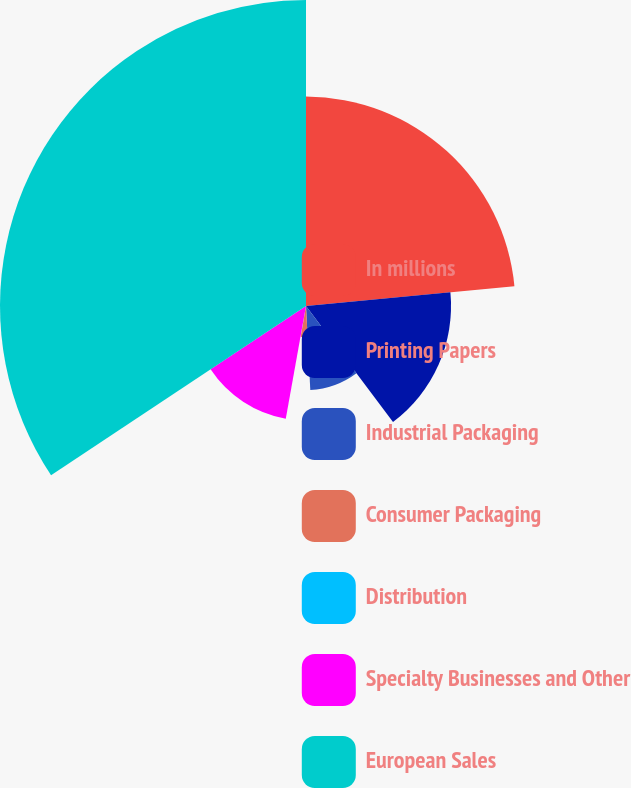Convert chart to OTSL. <chart><loc_0><loc_0><loc_500><loc_500><pie_chart><fcel>In millions<fcel>Printing Papers<fcel>Industrial Packaging<fcel>Consumer Packaging<fcel>Distribution<fcel>Specialty Businesses and Other<fcel>European Sales<nl><fcel>23.49%<fcel>16.27%<fcel>9.43%<fcel>3.53%<fcel>0.11%<fcel>12.85%<fcel>34.33%<nl></chart> 